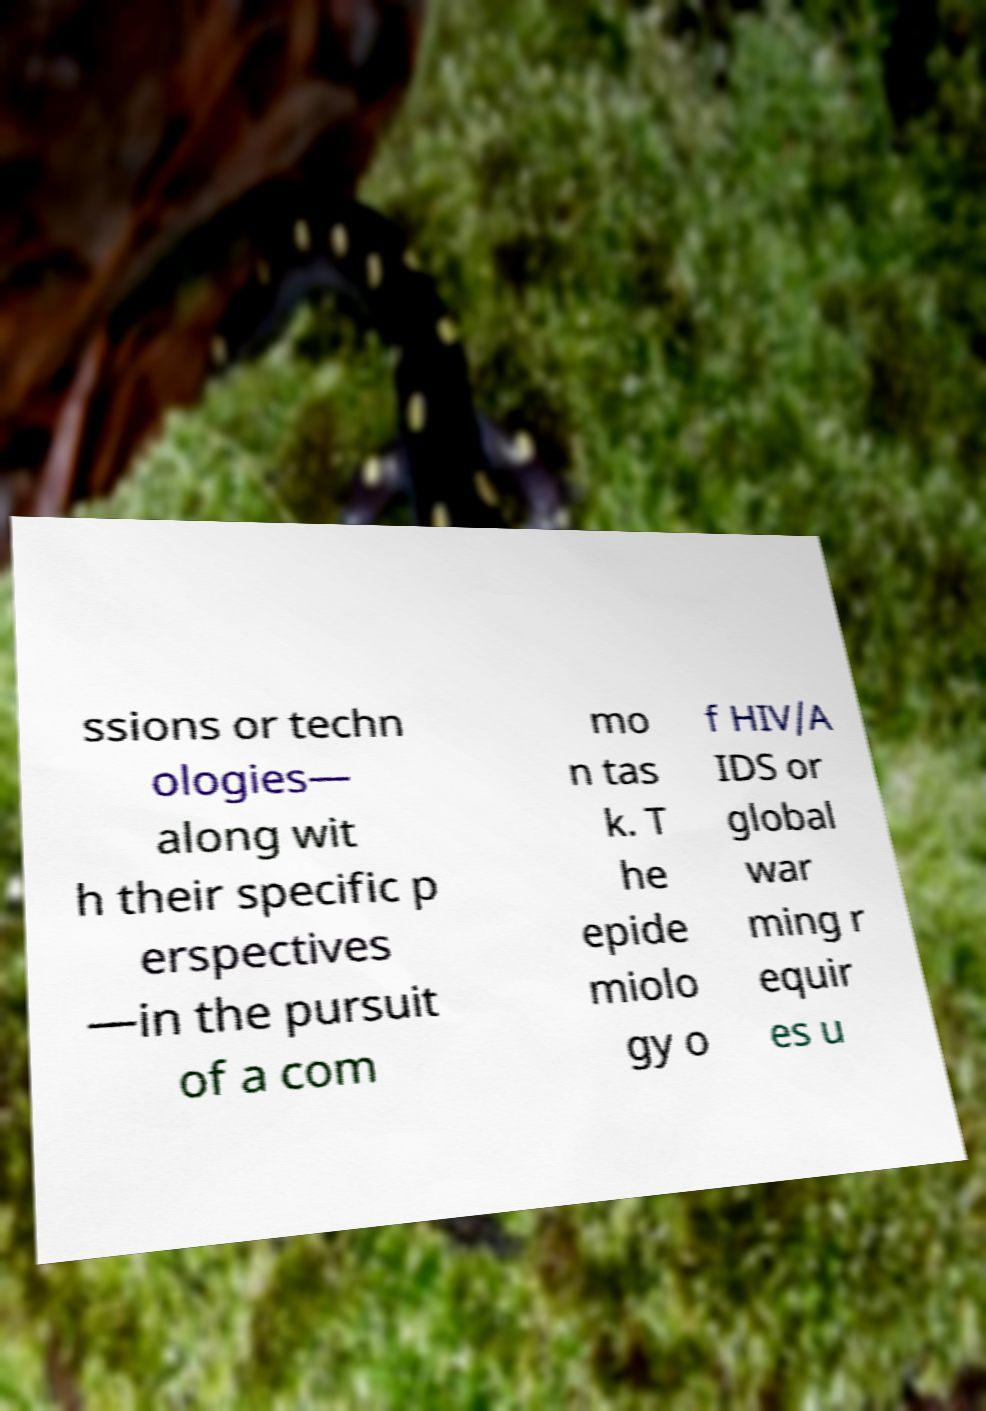Can you accurately transcribe the text from the provided image for me? ssions or techn ologies— along wit h their specific p erspectives —in the pursuit of a com mo n tas k. T he epide miolo gy o f HIV/A IDS or global war ming r equir es u 